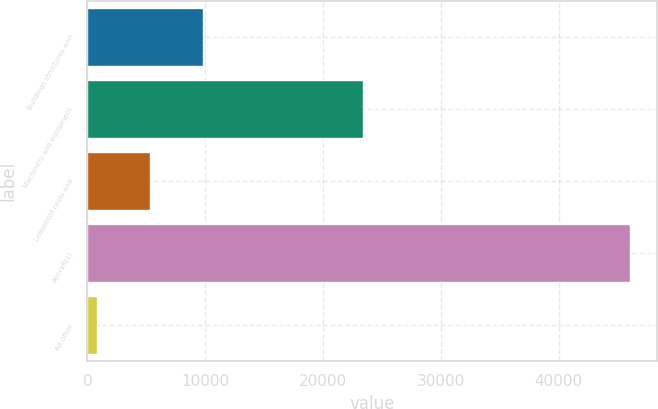Convert chart. <chart><loc_0><loc_0><loc_500><loc_500><bar_chart><fcel>Buildings structures and<fcel>Machinery and equipment<fcel>Leasehold costs and<fcel>Aircraft(c)<fcel>All other<nl><fcel>9817<fcel>23370<fcel>5292<fcel>46017<fcel>767<nl></chart> 